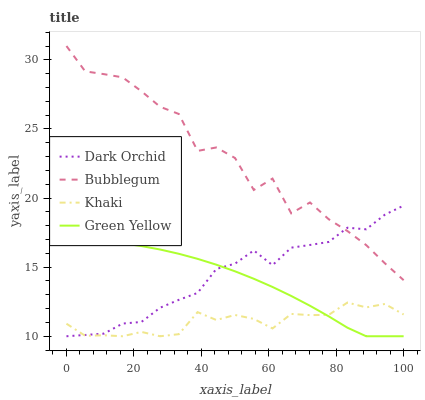Does Khaki have the minimum area under the curve?
Answer yes or no. Yes. Does Bubblegum have the maximum area under the curve?
Answer yes or no. Yes. Does Bubblegum have the minimum area under the curve?
Answer yes or no. No. Does Khaki have the maximum area under the curve?
Answer yes or no. No. Is Green Yellow the smoothest?
Answer yes or no. Yes. Is Bubblegum the roughest?
Answer yes or no. Yes. Is Khaki the smoothest?
Answer yes or no. No. Is Khaki the roughest?
Answer yes or no. No. Does Bubblegum have the lowest value?
Answer yes or no. No. Does Bubblegum have the highest value?
Answer yes or no. Yes. Does Khaki have the highest value?
Answer yes or no. No. Is Khaki less than Bubblegum?
Answer yes or no. Yes. Is Bubblegum greater than Khaki?
Answer yes or no. Yes. Does Green Yellow intersect Khaki?
Answer yes or no. Yes. Is Green Yellow less than Khaki?
Answer yes or no. No. Is Green Yellow greater than Khaki?
Answer yes or no. No. Does Khaki intersect Bubblegum?
Answer yes or no. No. 